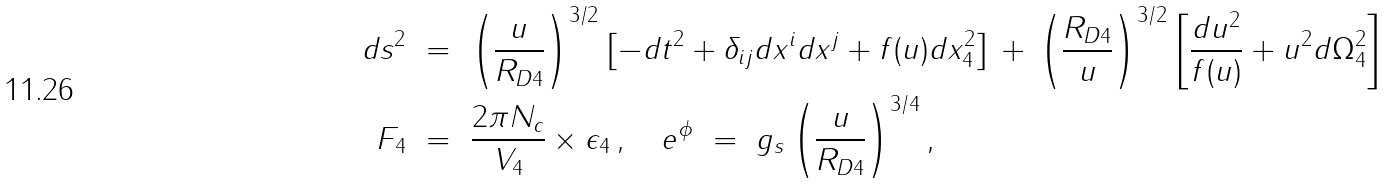Convert formula to latex. <formula><loc_0><loc_0><loc_500><loc_500>d s ^ { 2 } \ & = \ \left ( \frac { u } { R _ { D 4 } } \right ) ^ { 3 / 2 } \left [ - d t ^ { 2 } + \delta _ { i j } d x ^ { i } d x ^ { j } + f ( u ) d x _ { 4 } ^ { 2 } \right ] \, + \, \left ( \frac { R _ { D 4 } } { u } \right ) ^ { 3 / 2 } \left [ \frac { d u ^ { 2 } } { f ( u ) } + u ^ { 2 } d \Omega _ { 4 } ^ { 2 } \right ] \\ F _ { 4 } \ & = \ \frac { 2 \pi N _ { c } } { V _ { 4 } } \times \epsilon _ { 4 } \, , \quad e ^ { \phi } \ = \ g _ { s } \left ( \frac { u } { R _ { D 4 } } \right ) ^ { 3 / 4 } ,</formula> 